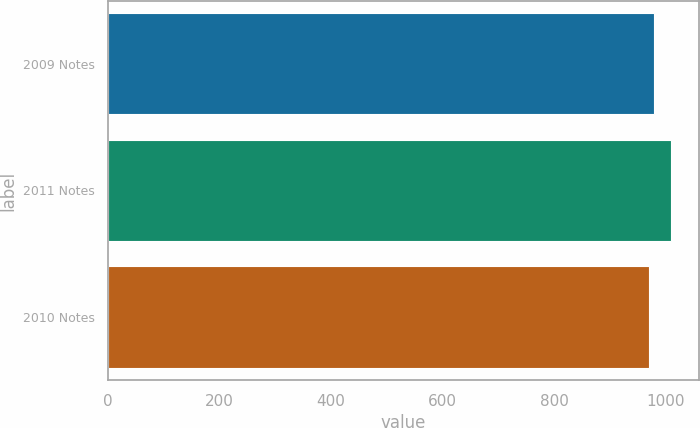Convert chart to OTSL. <chart><loc_0><loc_0><loc_500><loc_500><bar_chart><fcel>2009 Notes<fcel>2011 Notes<fcel>2010 Notes<nl><fcel>980<fcel>1010<fcel>970<nl></chart> 